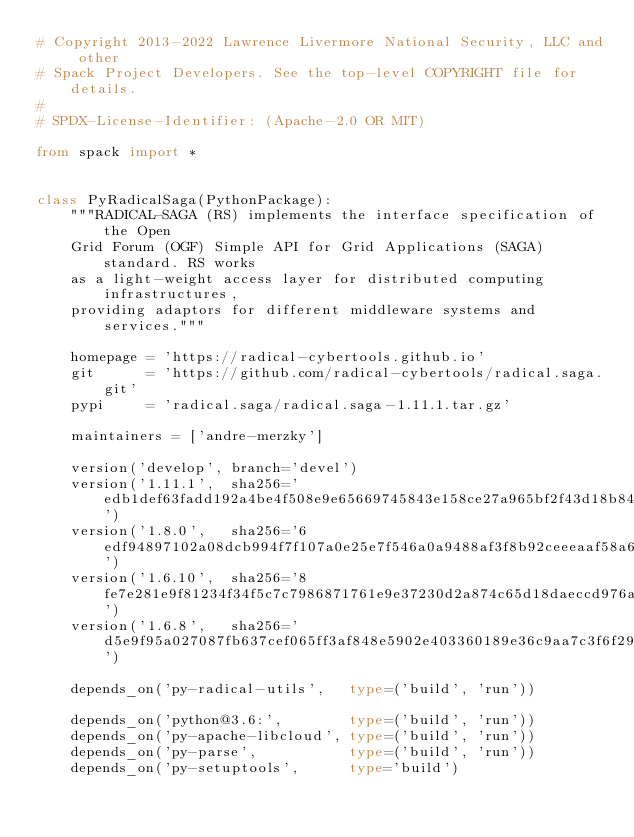<code> <loc_0><loc_0><loc_500><loc_500><_Python_># Copyright 2013-2022 Lawrence Livermore National Security, LLC and other
# Spack Project Developers. See the top-level COPYRIGHT file for details.
#
# SPDX-License-Identifier: (Apache-2.0 OR MIT)

from spack import *


class PyRadicalSaga(PythonPackage):
    """RADICAL-SAGA (RS) implements the interface specification of the Open
    Grid Forum (OGF) Simple API for Grid Applications (SAGA) standard. RS works
    as a light-weight access layer for distributed computing infrastructures,
    providing adaptors for different middleware systems and services."""

    homepage = 'https://radical-cybertools.github.io'
    git      = 'https://github.com/radical-cybertools/radical.saga.git'
    pypi     = 'radical.saga/radical.saga-1.11.1.tar.gz'

    maintainers = ['andre-merzky']

    version('develop', branch='devel')
    version('1.11.1',  sha256='edb1def63fadd192a4be4f508e9e65669745843e158ce27a965bf2f43d18b84d')
    version('1.8.0',   sha256='6edf94897102a08dcb994f7f107a0e25e7f546a0a9488af3f8b92ceeeaaf58a6')
    version('1.6.10',  sha256='8fe7e281e9f81234f34f5c7c7986871761e9e37230d2a874c65d18daeccd976a')
    version('1.6.8',   sha256='d5e9f95a027087fb637cef065ff3af848e5902e403360189e36c9aa7c3f6f29b')

    depends_on('py-radical-utils',   type=('build', 'run'))

    depends_on('python@3.6:',        type=('build', 'run'))
    depends_on('py-apache-libcloud', type=('build', 'run'))
    depends_on('py-parse',           type=('build', 'run'))
    depends_on('py-setuptools',      type='build')
</code> 